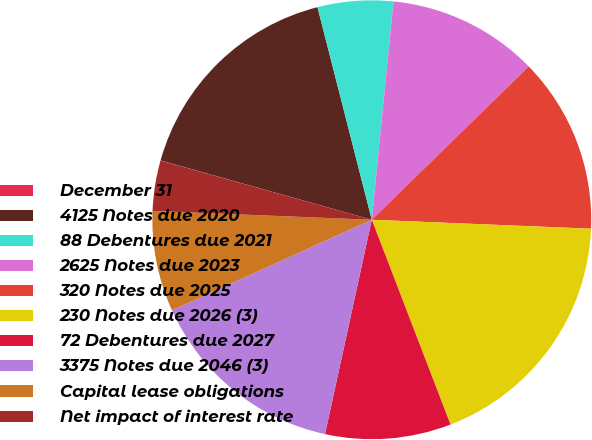<chart> <loc_0><loc_0><loc_500><loc_500><pie_chart><fcel>December 31<fcel>4125 Notes due 2020<fcel>88 Debentures due 2021<fcel>2625 Notes due 2023<fcel>320 Notes due 2025<fcel>230 Notes due 2026 (3)<fcel>72 Debentures due 2027<fcel>3375 Notes due 2046 (3)<fcel>Capital lease obligations<fcel>Net impact of interest rate<nl><fcel>0.01%<fcel>16.66%<fcel>5.56%<fcel>11.11%<fcel>12.96%<fcel>18.51%<fcel>9.26%<fcel>14.81%<fcel>7.41%<fcel>3.71%<nl></chart> 